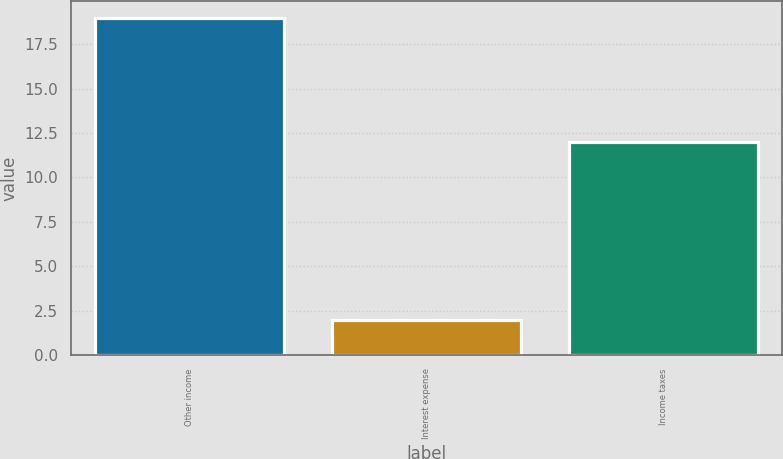Convert chart. <chart><loc_0><loc_0><loc_500><loc_500><bar_chart><fcel>Other income<fcel>Interest expense<fcel>Income taxes<nl><fcel>19<fcel>2<fcel>12<nl></chart> 